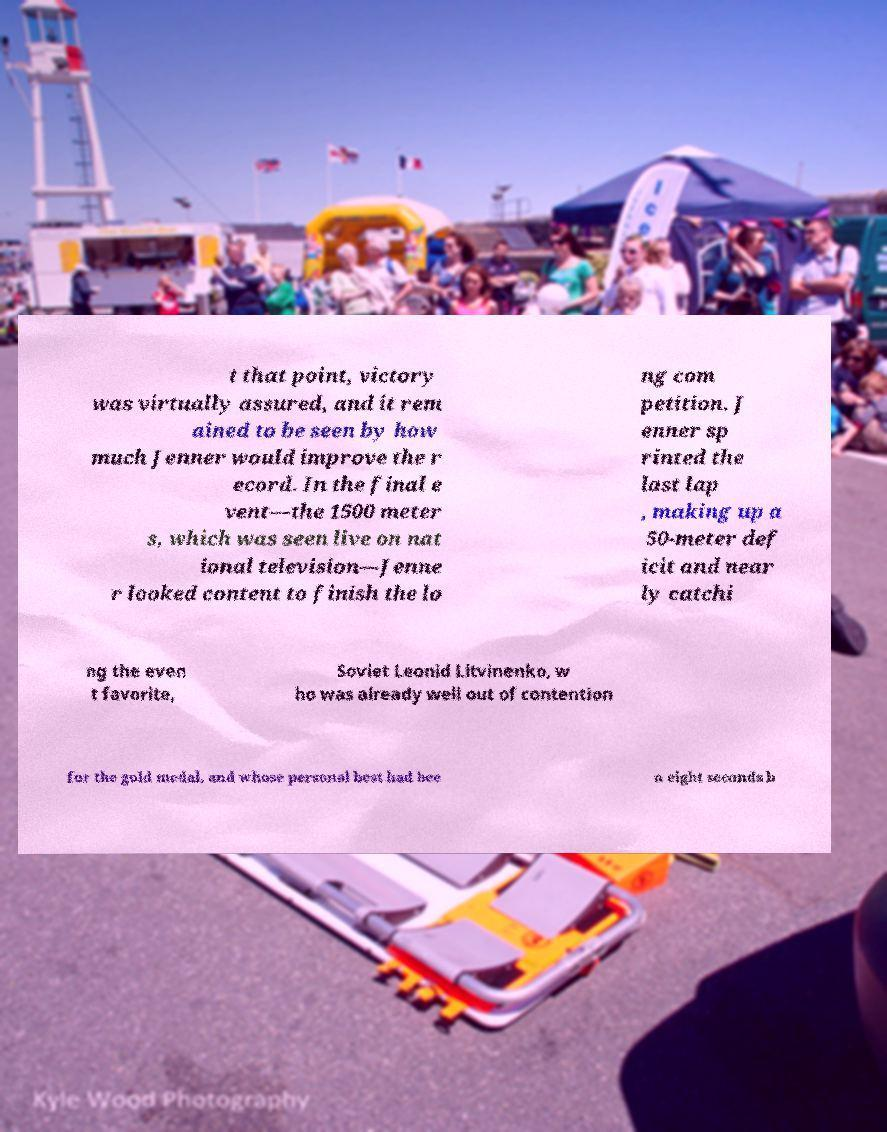Could you assist in decoding the text presented in this image and type it out clearly? t that point, victory was virtually assured, and it rem ained to be seen by how much Jenner would improve the r ecord. In the final e vent—the 1500 meter s, which was seen live on nat ional television—Jenne r looked content to finish the lo ng com petition. J enner sp rinted the last lap , making up a 50-meter def icit and near ly catchi ng the even t favorite, Soviet Leonid Litvinenko, w ho was already well out of contention for the gold medal, and whose personal best had bee n eight seconds b 